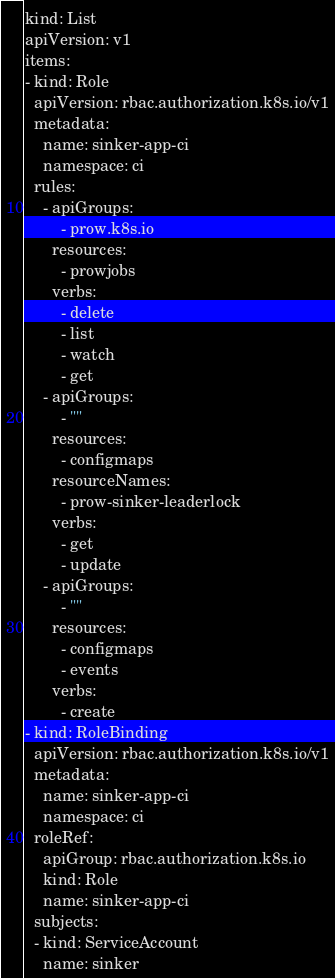<code> <loc_0><loc_0><loc_500><loc_500><_YAML_>kind: List
apiVersion: v1
items:
- kind: Role
  apiVersion: rbac.authorization.k8s.io/v1
  metadata:
    name: sinker-app-ci
    namespace: ci
  rules:
    - apiGroups:
        - prow.k8s.io
      resources:
        - prowjobs
      verbs:
        - delete
        - list
        - watch
        - get
    - apiGroups:
        - ""
      resources:
        - configmaps
      resourceNames:
        - prow-sinker-leaderlock
      verbs:
        - get
        - update
    - apiGroups:
        - ""
      resources:
        - configmaps
        - events
      verbs:
        - create
- kind: RoleBinding
  apiVersion: rbac.authorization.k8s.io/v1
  metadata:
    name: sinker-app-ci
    namespace: ci
  roleRef:
    apiGroup: rbac.authorization.k8s.io
    kind: Role
    name: sinker-app-ci
  subjects:
  - kind: ServiceAccount
    name: sinker
</code> 